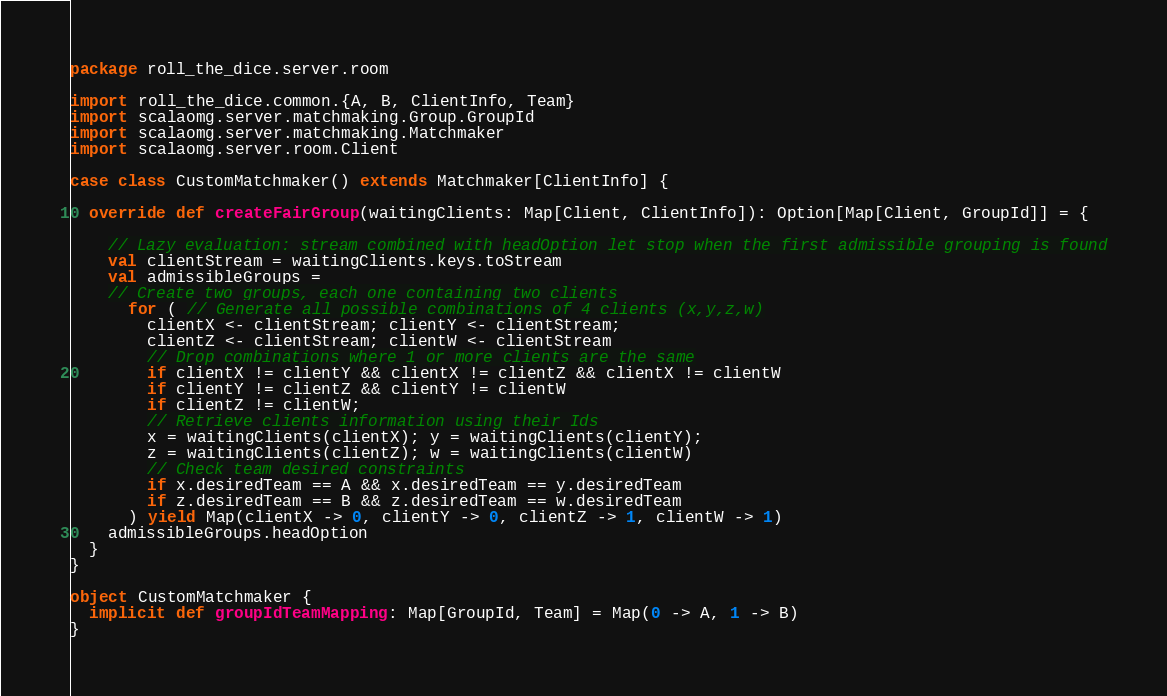Convert code to text. <code><loc_0><loc_0><loc_500><loc_500><_Scala_>package roll_the_dice.server.room

import roll_the_dice.common.{A, B, ClientInfo, Team}
import scalaomg.server.matchmaking.Group.GroupId
import scalaomg.server.matchmaking.Matchmaker
import scalaomg.server.room.Client

case class CustomMatchmaker() extends Matchmaker[ClientInfo] {

  override def createFairGroup(waitingClients: Map[Client, ClientInfo]): Option[Map[Client, GroupId]] = {

    // Lazy evaluation: stream combined with headOption let stop when the first admissible grouping is found
    val clientStream = waitingClients.keys.toStream
    val admissibleGroups =
    // Create two groups, each one containing two clients
      for ( // Generate all possible combinations of 4 clients (x,y,z,w)
        clientX <- clientStream; clientY <- clientStream;
        clientZ <- clientStream; clientW <- clientStream
        // Drop combinations where 1 or more clients are the same
        if clientX != clientY && clientX != clientZ && clientX != clientW
        if clientY != clientZ && clientY != clientW
        if clientZ != clientW;
        // Retrieve clients information using their Ids
        x = waitingClients(clientX); y = waitingClients(clientY);
        z = waitingClients(clientZ); w = waitingClients(clientW)
        // Check team desired constraints
        if x.desiredTeam == A && x.desiredTeam == y.desiredTeam
        if z.desiredTeam == B && z.desiredTeam == w.desiredTeam
      ) yield Map(clientX -> 0, clientY -> 0, clientZ -> 1, clientW -> 1)
    admissibleGroups.headOption
  }
}

object CustomMatchmaker {
  implicit def groupIdTeamMapping: Map[GroupId, Team] = Map(0 -> A, 1 -> B)
}
</code> 